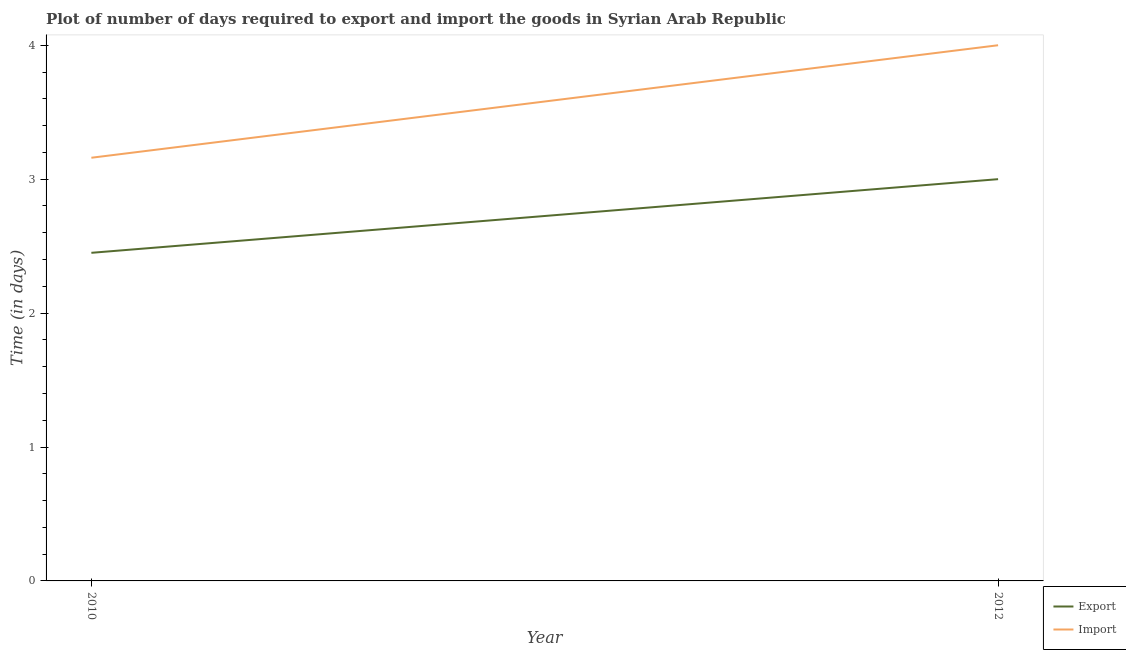Is the number of lines equal to the number of legend labels?
Offer a very short reply. Yes. What is the time required to export in 2010?
Give a very brief answer. 2.45. Across all years, what is the maximum time required to import?
Your answer should be compact. 4. Across all years, what is the minimum time required to import?
Provide a succinct answer. 3.16. In which year was the time required to import minimum?
Provide a succinct answer. 2010. What is the total time required to export in the graph?
Your answer should be compact. 5.45. What is the difference between the time required to export in 2010 and that in 2012?
Keep it short and to the point. -0.55. What is the difference between the time required to import in 2012 and the time required to export in 2010?
Offer a very short reply. 1.55. What is the average time required to import per year?
Offer a terse response. 3.58. In the year 2010, what is the difference between the time required to import and time required to export?
Keep it short and to the point. 0.71. What is the ratio of the time required to export in 2010 to that in 2012?
Keep it short and to the point. 0.82. Is the time required to import in 2010 less than that in 2012?
Provide a succinct answer. Yes. In how many years, is the time required to export greater than the average time required to export taken over all years?
Make the answer very short. 1. Is the time required to import strictly greater than the time required to export over the years?
Offer a very short reply. Yes. How many lines are there?
Make the answer very short. 2. How many years are there in the graph?
Provide a succinct answer. 2. Does the graph contain grids?
Your answer should be compact. No. How many legend labels are there?
Make the answer very short. 2. What is the title of the graph?
Keep it short and to the point. Plot of number of days required to export and import the goods in Syrian Arab Republic. What is the label or title of the X-axis?
Ensure brevity in your answer.  Year. What is the label or title of the Y-axis?
Your response must be concise. Time (in days). What is the Time (in days) in Export in 2010?
Your answer should be very brief. 2.45. What is the Time (in days) in Import in 2010?
Offer a very short reply. 3.16. What is the Time (in days) of Export in 2012?
Provide a short and direct response. 3. What is the Time (in days) of Import in 2012?
Ensure brevity in your answer.  4. Across all years, what is the minimum Time (in days) of Export?
Provide a short and direct response. 2.45. Across all years, what is the minimum Time (in days) of Import?
Provide a succinct answer. 3.16. What is the total Time (in days) of Export in the graph?
Keep it short and to the point. 5.45. What is the total Time (in days) of Import in the graph?
Provide a succinct answer. 7.16. What is the difference between the Time (in days) in Export in 2010 and that in 2012?
Your response must be concise. -0.55. What is the difference between the Time (in days) in Import in 2010 and that in 2012?
Provide a succinct answer. -0.84. What is the difference between the Time (in days) in Export in 2010 and the Time (in days) in Import in 2012?
Your answer should be very brief. -1.55. What is the average Time (in days) in Export per year?
Provide a succinct answer. 2.73. What is the average Time (in days) in Import per year?
Keep it short and to the point. 3.58. In the year 2010, what is the difference between the Time (in days) of Export and Time (in days) of Import?
Offer a very short reply. -0.71. In the year 2012, what is the difference between the Time (in days) of Export and Time (in days) of Import?
Ensure brevity in your answer.  -1. What is the ratio of the Time (in days) of Export in 2010 to that in 2012?
Provide a short and direct response. 0.82. What is the ratio of the Time (in days) of Import in 2010 to that in 2012?
Make the answer very short. 0.79. What is the difference between the highest and the second highest Time (in days) of Export?
Keep it short and to the point. 0.55. What is the difference between the highest and the second highest Time (in days) of Import?
Ensure brevity in your answer.  0.84. What is the difference between the highest and the lowest Time (in days) in Export?
Keep it short and to the point. 0.55. What is the difference between the highest and the lowest Time (in days) in Import?
Offer a terse response. 0.84. 